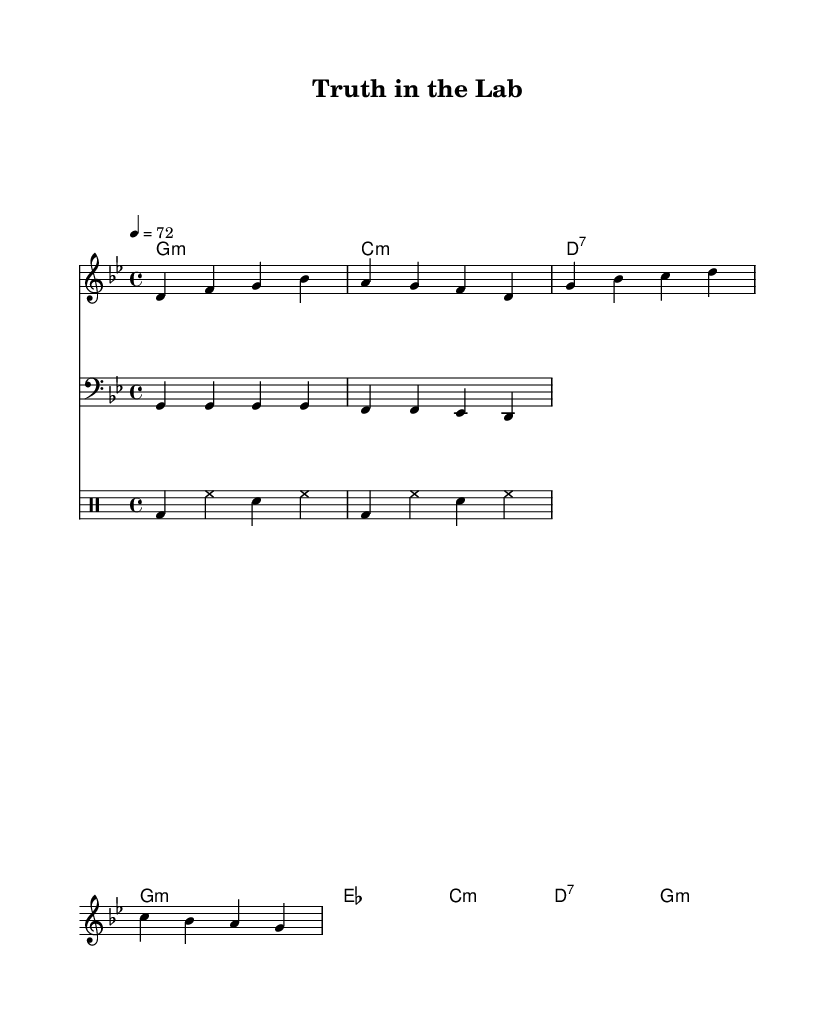What is the time signature of this music? The time signature is indicated at the beginning of the sheet music, which shows 4/4. This means there are four beats in each measure, and the quarter note gets one beat.
Answer: 4/4 What is the key signature of this music? The key signature is placed at the beginning of the staff. In this case, it indicates G minor, which has two flats (B flat and E flat).
Answer: G minor What is the tempo marking for this music piece? The tempo is noted above the staff as "4 = 72," which indicates that a quarter note is to be played at 72 beats per minute.
Answer: 72 How many measures are in the verse section? The verse section of the sheet music consists of four measures as seen in the melody line, each separated by a vertical line.
Answer: 4 How does the bassline contribute to the reggae style of this piece? In reggae music, the bassline generally plays a rhythmic role that is laid-back and often emphasizes the off-beat. The provided bassline consistently holds the notes with a steady rhythm, characteristic of the style.
Answer: Off-beat rhythm What is the main theme of the song as inferred from the lyrics? The lyrics present themes of scientific integrity and ethical research practices. The phrase "Let the data speak" emphasizes the importance of honesty and transparency in research.
Answer: Scientific integrity What does "g:m" represent in the chord names? The chord name "g:m" indicates a G minor chord, which is a common chord used in many music styles, including reggae. The "m" stands for minor, implying a specific emotional tone that fits the reggae genre.
Answer: G minor 